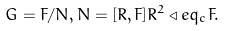<formula> <loc_0><loc_0><loc_500><loc_500>G = F / N , N = [ R , F ] R ^ { 2 } \triangleleft e q _ { c } F .</formula> 